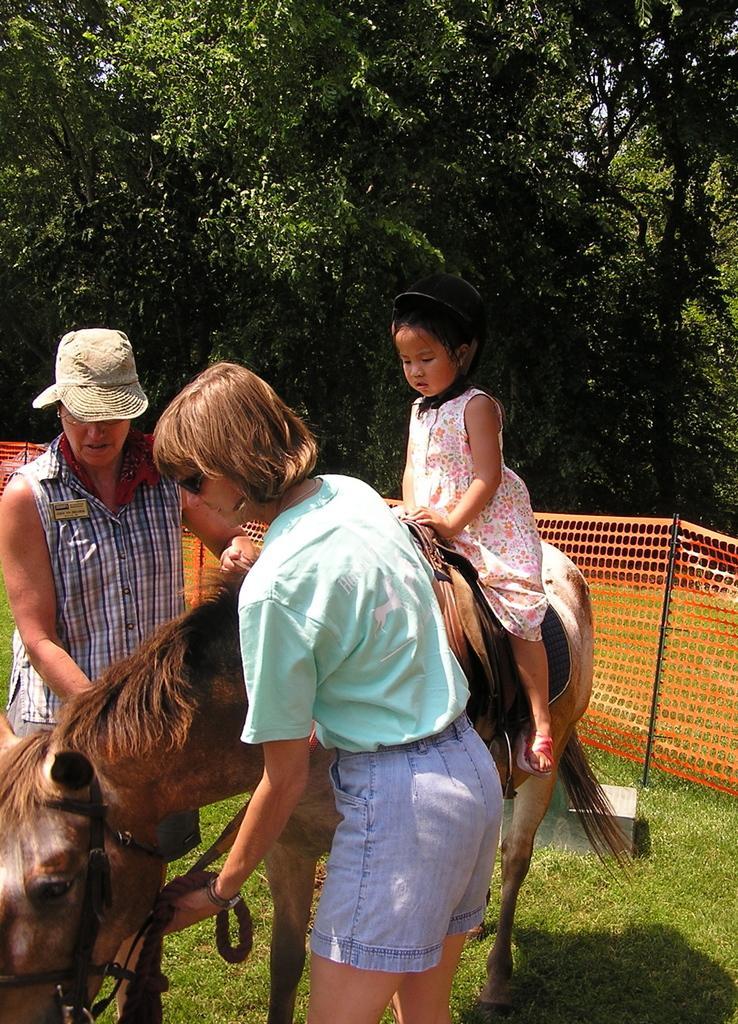In one or two sentences, can you explain what this image depicts? In this picture their is girl child sitting on a horse and two women are holding the belt of horse. The woman to the left side is wearing a cap. At the background there is net,trees. At the bottom there is grass. 